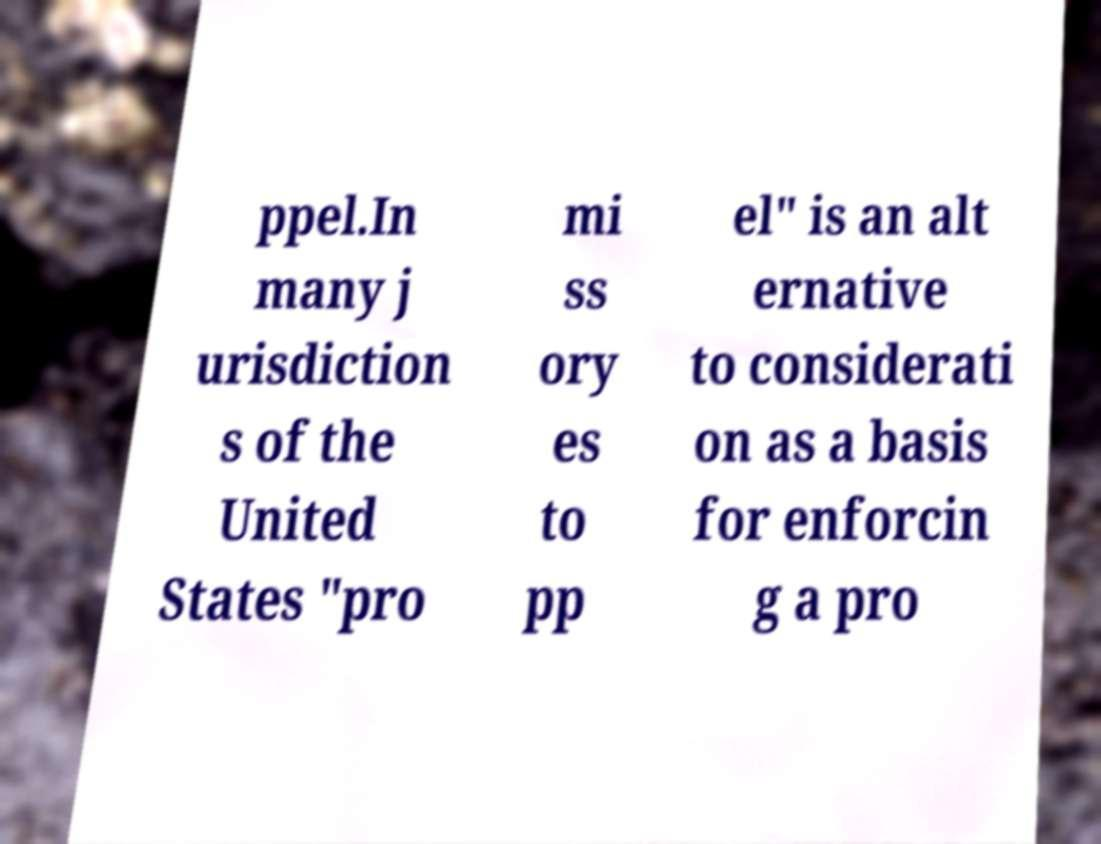There's text embedded in this image that I need extracted. Can you transcribe it verbatim? ppel.In many j urisdiction s of the United States "pro mi ss ory es to pp el" is an alt ernative to considerati on as a basis for enforcin g a pro 